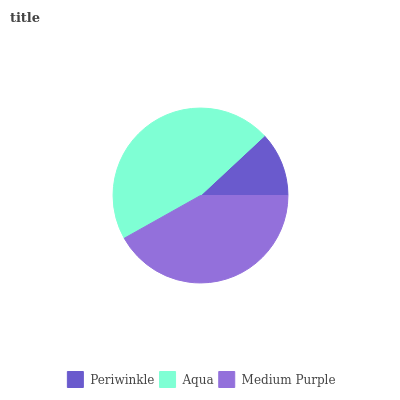Is Periwinkle the minimum?
Answer yes or no. Yes. Is Aqua the maximum?
Answer yes or no. Yes. Is Medium Purple the minimum?
Answer yes or no. No. Is Medium Purple the maximum?
Answer yes or no. No. Is Aqua greater than Medium Purple?
Answer yes or no. Yes. Is Medium Purple less than Aqua?
Answer yes or no. Yes. Is Medium Purple greater than Aqua?
Answer yes or no. No. Is Aqua less than Medium Purple?
Answer yes or no. No. Is Medium Purple the high median?
Answer yes or no. Yes. Is Medium Purple the low median?
Answer yes or no. Yes. Is Aqua the high median?
Answer yes or no. No. Is Aqua the low median?
Answer yes or no. No. 